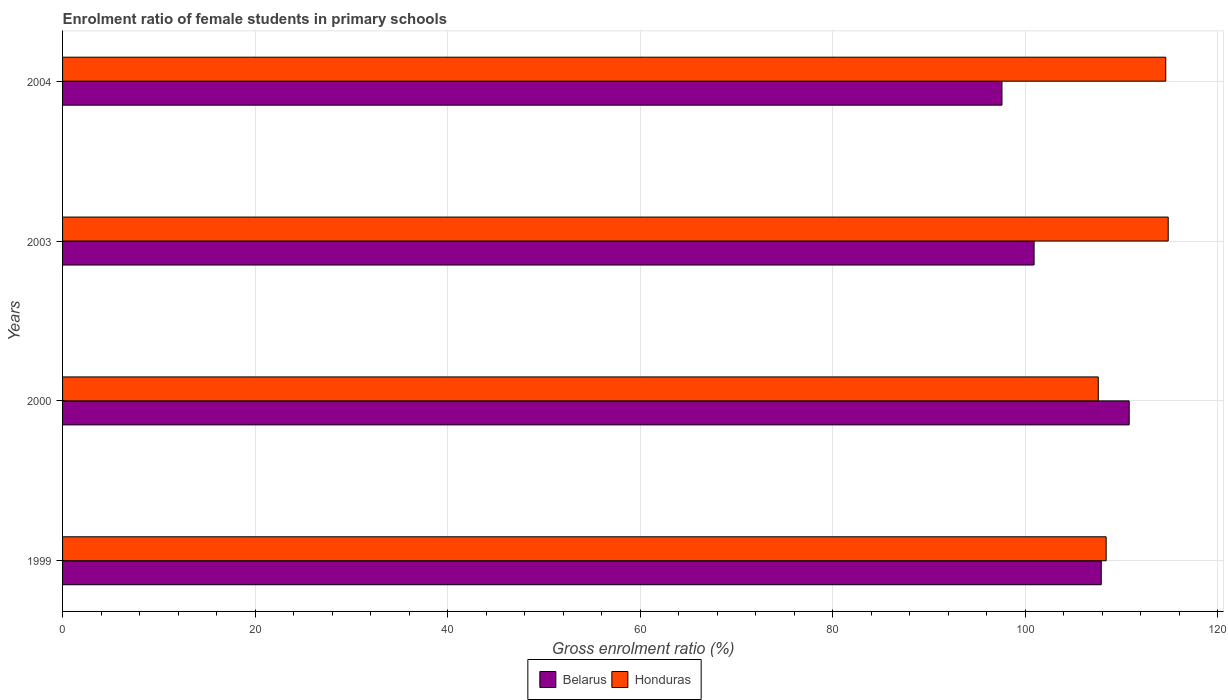How many different coloured bars are there?
Provide a short and direct response. 2. How many groups of bars are there?
Offer a very short reply. 4. Are the number of bars on each tick of the Y-axis equal?
Offer a very short reply. Yes. How many bars are there on the 2nd tick from the top?
Provide a short and direct response. 2. How many bars are there on the 2nd tick from the bottom?
Your answer should be compact. 2. What is the enrolment ratio of female students in primary schools in Honduras in 2003?
Ensure brevity in your answer.  114.85. Across all years, what is the maximum enrolment ratio of female students in primary schools in Honduras?
Offer a terse response. 114.85. Across all years, what is the minimum enrolment ratio of female students in primary schools in Honduras?
Provide a succinct answer. 107.59. In which year was the enrolment ratio of female students in primary schools in Honduras minimum?
Your answer should be compact. 2000. What is the total enrolment ratio of female students in primary schools in Belarus in the graph?
Provide a succinct answer. 417.19. What is the difference between the enrolment ratio of female students in primary schools in Belarus in 2003 and that in 2004?
Keep it short and to the point. 3.34. What is the difference between the enrolment ratio of female students in primary schools in Belarus in 2004 and the enrolment ratio of female students in primary schools in Honduras in 2003?
Give a very brief answer. -17.27. What is the average enrolment ratio of female students in primary schools in Honduras per year?
Your response must be concise. 111.36. In the year 1999, what is the difference between the enrolment ratio of female students in primary schools in Honduras and enrolment ratio of female students in primary schools in Belarus?
Offer a very short reply. 0.51. What is the ratio of the enrolment ratio of female students in primary schools in Honduras in 2000 to that in 2003?
Keep it short and to the point. 0.94. Is the enrolment ratio of female students in primary schools in Belarus in 1999 less than that in 2003?
Offer a terse response. No. What is the difference between the highest and the second highest enrolment ratio of female students in primary schools in Honduras?
Your response must be concise. 0.25. What is the difference between the highest and the lowest enrolment ratio of female students in primary schools in Belarus?
Give a very brief answer. 13.22. What does the 1st bar from the top in 2004 represents?
Keep it short and to the point. Honduras. What does the 1st bar from the bottom in 2000 represents?
Ensure brevity in your answer.  Belarus. Are the values on the major ticks of X-axis written in scientific E-notation?
Provide a short and direct response. No. Does the graph contain any zero values?
Provide a short and direct response. No. How many legend labels are there?
Make the answer very short. 2. How are the legend labels stacked?
Give a very brief answer. Horizontal. What is the title of the graph?
Your answer should be compact. Enrolment ratio of female students in primary schools. Does "OECD members" appear as one of the legend labels in the graph?
Make the answer very short. No. What is the label or title of the X-axis?
Provide a short and direct response. Gross enrolment ratio (%). What is the label or title of the Y-axis?
Give a very brief answer. Years. What is the Gross enrolment ratio (%) of Belarus in 1999?
Keep it short and to the point. 107.89. What is the Gross enrolment ratio (%) in Honduras in 1999?
Make the answer very short. 108.4. What is the Gross enrolment ratio (%) in Belarus in 2000?
Ensure brevity in your answer.  110.8. What is the Gross enrolment ratio (%) of Honduras in 2000?
Ensure brevity in your answer.  107.59. What is the Gross enrolment ratio (%) of Belarus in 2003?
Offer a terse response. 100.92. What is the Gross enrolment ratio (%) of Honduras in 2003?
Your response must be concise. 114.85. What is the Gross enrolment ratio (%) in Belarus in 2004?
Your answer should be very brief. 97.58. What is the Gross enrolment ratio (%) of Honduras in 2004?
Provide a succinct answer. 114.59. Across all years, what is the maximum Gross enrolment ratio (%) of Belarus?
Your answer should be very brief. 110.8. Across all years, what is the maximum Gross enrolment ratio (%) in Honduras?
Your answer should be compact. 114.85. Across all years, what is the minimum Gross enrolment ratio (%) of Belarus?
Your response must be concise. 97.58. Across all years, what is the minimum Gross enrolment ratio (%) in Honduras?
Keep it short and to the point. 107.59. What is the total Gross enrolment ratio (%) in Belarus in the graph?
Keep it short and to the point. 417.19. What is the total Gross enrolment ratio (%) of Honduras in the graph?
Ensure brevity in your answer.  445.43. What is the difference between the Gross enrolment ratio (%) of Belarus in 1999 and that in 2000?
Your answer should be compact. -2.9. What is the difference between the Gross enrolment ratio (%) in Honduras in 1999 and that in 2000?
Make the answer very short. 0.82. What is the difference between the Gross enrolment ratio (%) of Belarus in 1999 and that in 2003?
Your response must be concise. 6.98. What is the difference between the Gross enrolment ratio (%) in Honduras in 1999 and that in 2003?
Give a very brief answer. -6.45. What is the difference between the Gross enrolment ratio (%) in Belarus in 1999 and that in 2004?
Keep it short and to the point. 10.31. What is the difference between the Gross enrolment ratio (%) in Honduras in 1999 and that in 2004?
Provide a short and direct response. -6.19. What is the difference between the Gross enrolment ratio (%) in Belarus in 2000 and that in 2003?
Offer a terse response. 9.88. What is the difference between the Gross enrolment ratio (%) of Honduras in 2000 and that in 2003?
Your response must be concise. -7.26. What is the difference between the Gross enrolment ratio (%) of Belarus in 2000 and that in 2004?
Provide a succinct answer. 13.22. What is the difference between the Gross enrolment ratio (%) of Honduras in 2000 and that in 2004?
Provide a short and direct response. -7.01. What is the difference between the Gross enrolment ratio (%) in Belarus in 2003 and that in 2004?
Your answer should be very brief. 3.34. What is the difference between the Gross enrolment ratio (%) in Honduras in 2003 and that in 2004?
Offer a very short reply. 0.25. What is the difference between the Gross enrolment ratio (%) of Belarus in 1999 and the Gross enrolment ratio (%) of Honduras in 2000?
Your answer should be very brief. 0.31. What is the difference between the Gross enrolment ratio (%) of Belarus in 1999 and the Gross enrolment ratio (%) of Honduras in 2003?
Give a very brief answer. -6.95. What is the difference between the Gross enrolment ratio (%) in Belarus in 1999 and the Gross enrolment ratio (%) in Honduras in 2004?
Provide a succinct answer. -6.7. What is the difference between the Gross enrolment ratio (%) of Belarus in 2000 and the Gross enrolment ratio (%) of Honduras in 2003?
Provide a succinct answer. -4.05. What is the difference between the Gross enrolment ratio (%) of Belarus in 2000 and the Gross enrolment ratio (%) of Honduras in 2004?
Offer a terse response. -3.8. What is the difference between the Gross enrolment ratio (%) of Belarus in 2003 and the Gross enrolment ratio (%) of Honduras in 2004?
Provide a short and direct response. -13.68. What is the average Gross enrolment ratio (%) in Belarus per year?
Ensure brevity in your answer.  104.3. What is the average Gross enrolment ratio (%) in Honduras per year?
Your answer should be compact. 111.36. In the year 1999, what is the difference between the Gross enrolment ratio (%) in Belarus and Gross enrolment ratio (%) in Honduras?
Your answer should be compact. -0.51. In the year 2000, what is the difference between the Gross enrolment ratio (%) of Belarus and Gross enrolment ratio (%) of Honduras?
Keep it short and to the point. 3.21. In the year 2003, what is the difference between the Gross enrolment ratio (%) in Belarus and Gross enrolment ratio (%) in Honduras?
Offer a terse response. -13.93. In the year 2004, what is the difference between the Gross enrolment ratio (%) of Belarus and Gross enrolment ratio (%) of Honduras?
Your answer should be very brief. -17.02. What is the ratio of the Gross enrolment ratio (%) in Belarus in 1999 to that in 2000?
Keep it short and to the point. 0.97. What is the ratio of the Gross enrolment ratio (%) of Honduras in 1999 to that in 2000?
Make the answer very short. 1.01. What is the ratio of the Gross enrolment ratio (%) in Belarus in 1999 to that in 2003?
Provide a short and direct response. 1.07. What is the ratio of the Gross enrolment ratio (%) in Honduras in 1999 to that in 2003?
Your answer should be compact. 0.94. What is the ratio of the Gross enrolment ratio (%) in Belarus in 1999 to that in 2004?
Provide a succinct answer. 1.11. What is the ratio of the Gross enrolment ratio (%) in Honduras in 1999 to that in 2004?
Offer a terse response. 0.95. What is the ratio of the Gross enrolment ratio (%) in Belarus in 2000 to that in 2003?
Give a very brief answer. 1.1. What is the ratio of the Gross enrolment ratio (%) in Honduras in 2000 to that in 2003?
Your answer should be very brief. 0.94. What is the ratio of the Gross enrolment ratio (%) of Belarus in 2000 to that in 2004?
Your answer should be very brief. 1.14. What is the ratio of the Gross enrolment ratio (%) of Honduras in 2000 to that in 2004?
Give a very brief answer. 0.94. What is the ratio of the Gross enrolment ratio (%) in Belarus in 2003 to that in 2004?
Your answer should be compact. 1.03. What is the ratio of the Gross enrolment ratio (%) of Honduras in 2003 to that in 2004?
Offer a very short reply. 1. What is the difference between the highest and the second highest Gross enrolment ratio (%) of Belarus?
Your response must be concise. 2.9. What is the difference between the highest and the second highest Gross enrolment ratio (%) in Honduras?
Your answer should be very brief. 0.25. What is the difference between the highest and the lowest Gross enrolment ratio (%) of Belarus?
Your response must be concise. 13.22. What is the difference between the highest and the lowest Gross enrolment ratio (%) in Honduras?
Provide a succinct answer. 7.26. 